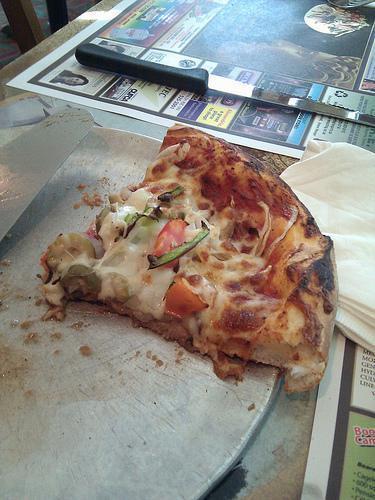How many pieces are left?
Give a very brief answer. 1. 